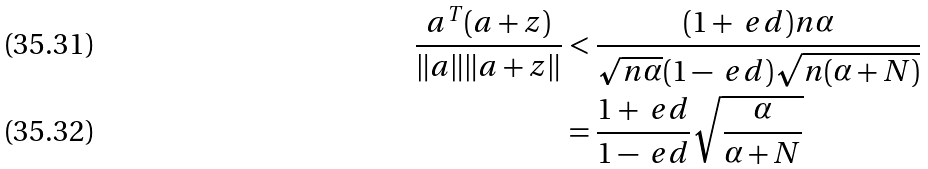<formula> <loc_0><loc_0><loc_500><loc_500>\frac { a ^ { T } ( a + z ) } { \| a \| \| a + z \| } & < \frac { ( 1 + \ e d ) n \alpha } { \sqrt { n \alpha } ( 1 - \ e d ) \sqrt { n ( \alpha + N ) } } \\ & = \frac { 1 + \ e d } { 1 - \ e d } \sqrt { \frac { \alpha } { \alpha + N } }</formula> 